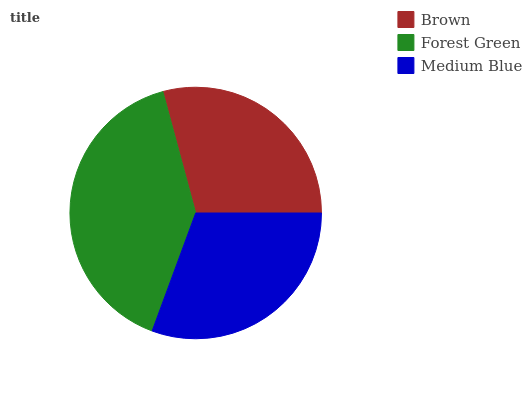Is Brown the minimum?
Answer yes or no. Yes. Is Forest Green the maximum?
Answer yes or no. Yes. Is Medium Blue the minimum?
Answer yes or no. No. Is Medium Blue the maximum?
Answer yes or no. No. Is Forest Green greater than Medium Blue?
Answer yes or no. Yes. Is Medium Blue less than Forest Green?
Answer yes or no. Yes. Is Medium Blue greater than Forest Green?
Answer yes or no. No. Is Forest Green less than Medium Blue?
Answer yes or no. No. Is Medium Blue the high median?
Answer yes or no. Yes. Is Medium Blue the low median?
Answer yes or no. Yes. Is Brown the high median?
Answer yes or no. No. Is Brown the low median?
Answer yes or no. No. 